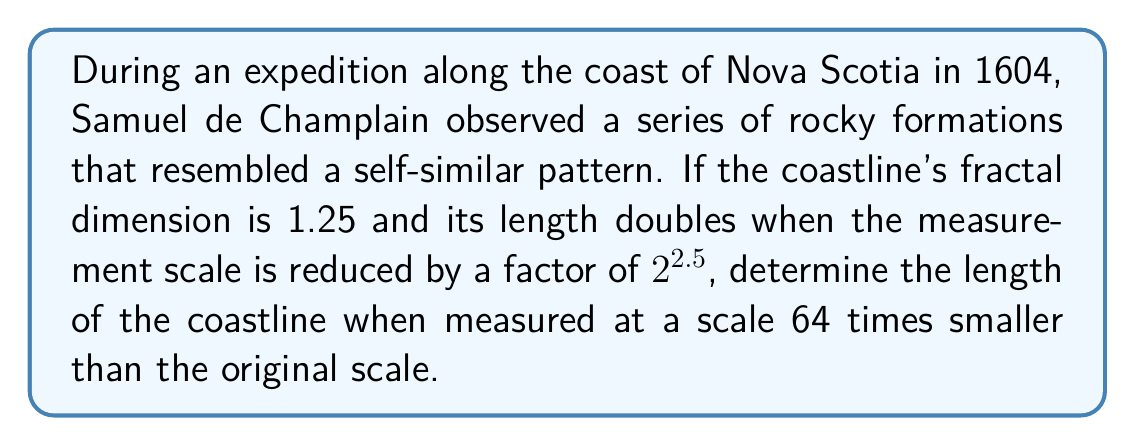Help me with this question. 1. Let's start with the fractal dimension formula:
   $$D = \frac{\log N}{\log(1/r)}$$
   where $D$ is the fractal dimension, $N$ is the number of self-similar pieces, and $r$ is the scaling factor.

2. We're given that $D = 1.25$ and the length doubles when the scale is reduced by $2^{2.5}$. This means:
   $$N = 2$$ (length doubles)
   $$r = \frac{1}{2^{2.5}}$$ (scale reduction)

3. Substituting these into the fractal dimension formula:
   $$1.25 = \frac{\log 2}{\log(2^{2.5})}$$

4. Now, we need to find how many times the length increases when the scale is reduced by a factor of 64:
   $$64 = 2^6$$
   So, we're looking at 6 iterations of the original scaling.

5. In each iteration, the length increases by a factor of 2. Over 6 iterations, the total increase is:
   $$2^6 = 64$$

6. Therefore, when measured at a scale 64 times smaller, the coastline length will be 64 times longer than the original measurement.
Answer: 64 times the original length 